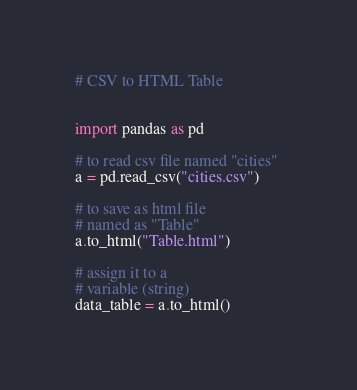<code> <loc_0><loc_0><loc_500><loc_500><_Python_># CSV to HTML Table 


import pandas as pd 

# to read csv file named "cities" 
a = pd.read_csv("cities.csv") 

# to save as html file 
# named as "Table" 
a.to_html("Table.html") 

# assign it to a 
# variable (string) 
data_table = a.to_html() 
</code> 